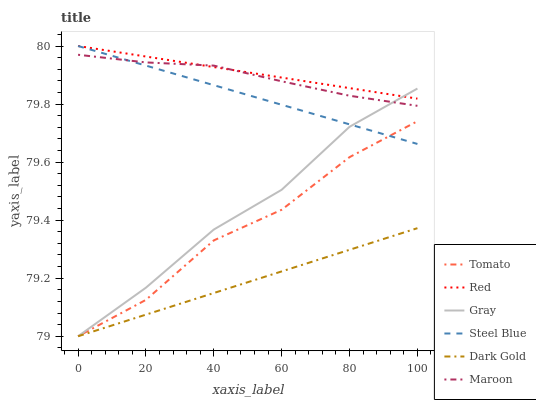Does Dark Gold have the minimum area under the curve?
Answer yes or no. Yes. Does Red have the maximum area under the curve?
Answer yes or no. Yes. Does Gray have the minimum area under the curve?
Answer yes or no. No. Does Gray have the maximum area under the curve?
Answer yes or no. No. Is Dark Gold the smoothest?
Answer yes or no. Yes. Is Tomato the roughest?
Answer yes or no. Yes. Is Gray the smoothest?
Answer yes or no. No. Is Gray the roughest?
Answer yes or no. No. Does Steel Blue have the lowest value?
Answer yes or no. No. Does Gray have the highest value?
Answer yes or no. No. Is Dark Gold less than Red?
Answer yes or no. Yes. Is Red greater than Tomato?
Answer yes or no. Yes. Does Dark Gold intersect Red?
Answer yes or no. No. 